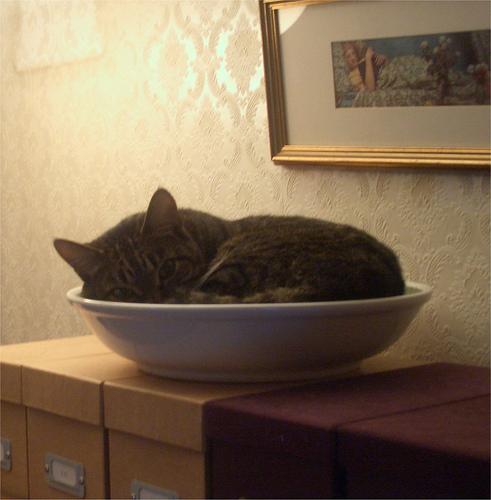Is the cat comfy?
Be succinct. Yes. Is the kitten curled up in a normal cat bed?
Be succinct. No. What color is the bowl?
Answer briefly. White. What are these dishes used for?
Keep it brief. Decor. 